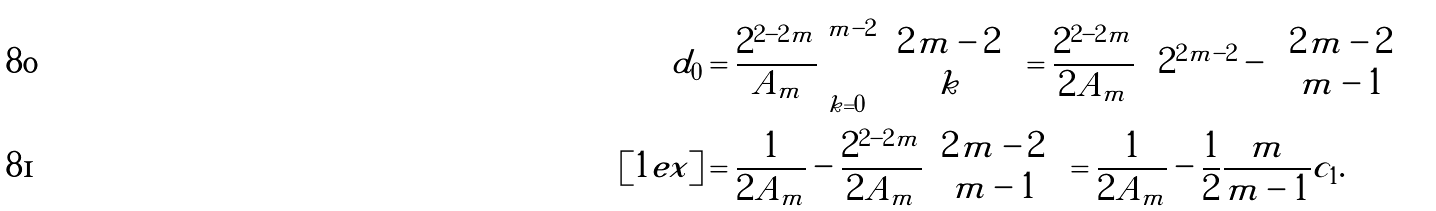Convert formula to latex. <formula><loc_0><loc_0><loc_500><loc_500>d _ { 0 } & = \frac { 2 ^ { 2 - 2 m } } { A _ { m } } \sum _ { k = 0 } ^ { m - 2 } \binom { 2 m - 2 } { k } = \frac { 2 ^ { 2 - 2 m } } { 2 A _ { m } } \left [ 2 ^ { 2 m - 2 } - \binom { 2 m - 2 } { m - 1 } \right ] \\ [ 1 e x ] & = \frac { 1 } { 2 A _ { m } } - \frac { 2 ^ { 2 - 2 m } } { 2 A _ { m } } \binom { 2 m - 2 } { m - 1 } = \frac { 1 } { 2 A _ { m } } - \frac { 1 } { 2 } \frac { m } { m - 1 } c _ { 1 } .</formula> 